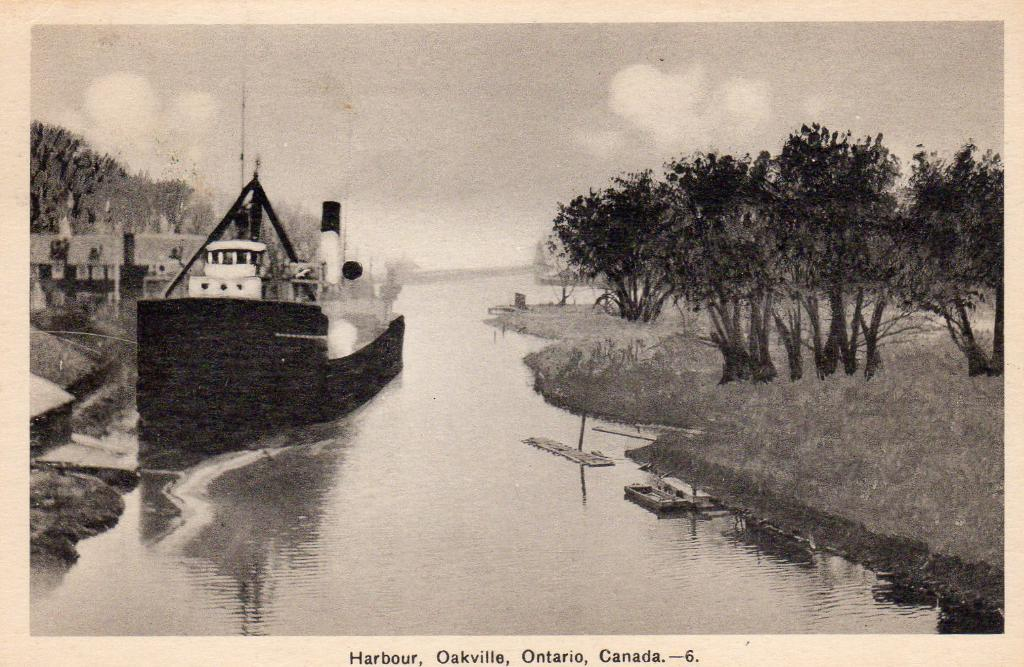<image>
Summarize the visual content of the image. A black and white postcard showing the harbour in Oakville, Ontario Canada. 